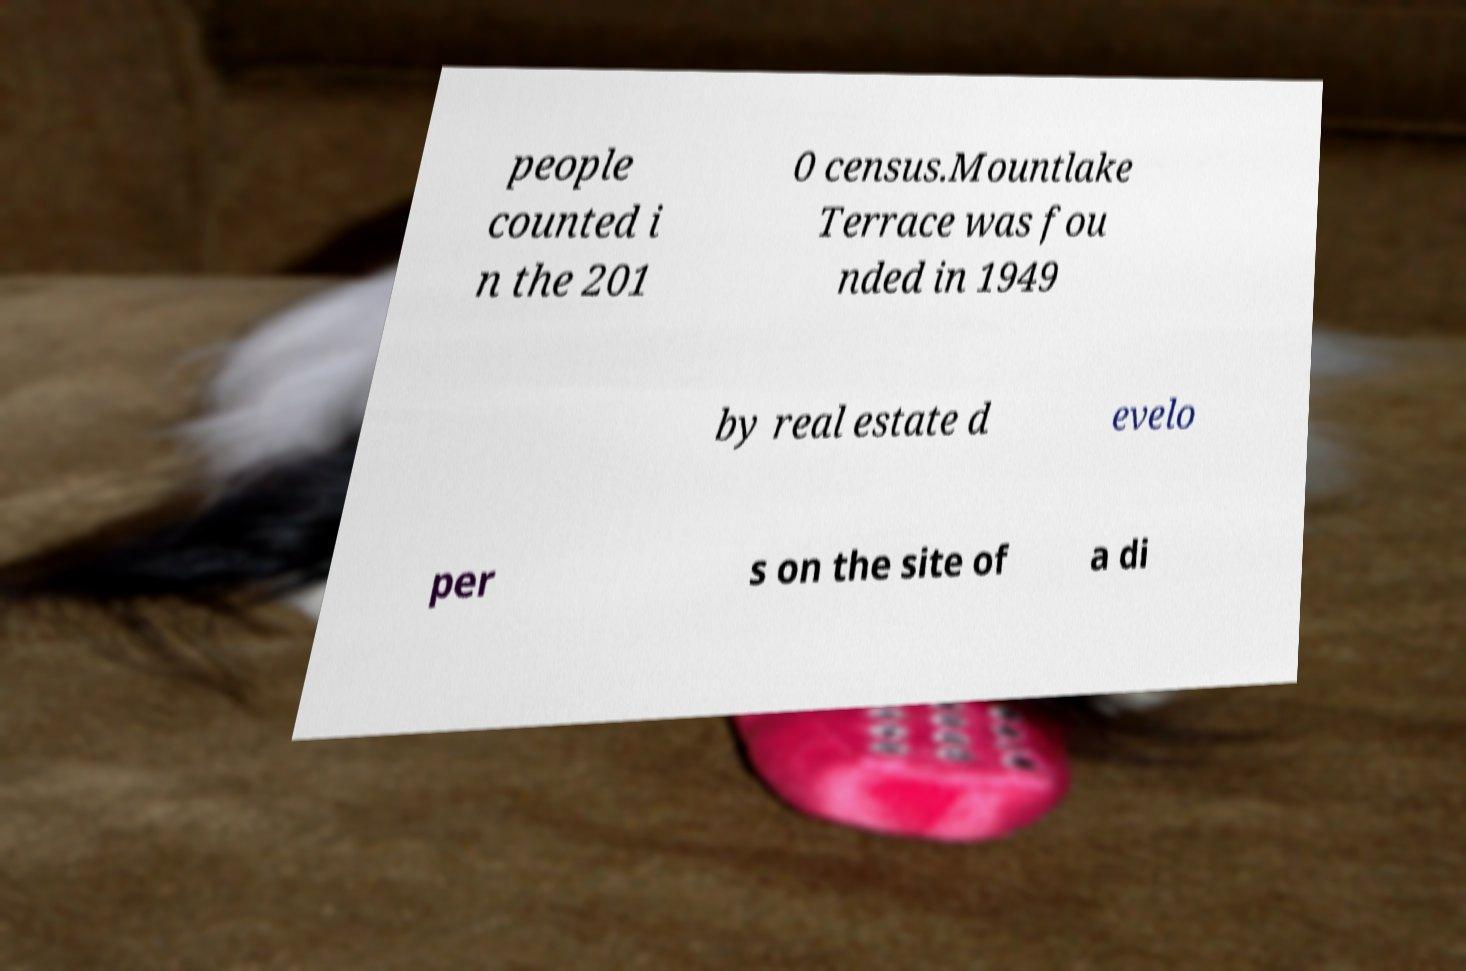What messages or text are displayed in this image? I need them in a readable, typed format. people counted i n the 201 0 census.Mountlake Terrace was fou nded in 1949 by real estate d evelo per s on the site of a di 